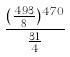Convert formula to latex. <formula><loc_0><loc_0><loc_500><loc_500>\frac { ( \frac { 4 9 3 } { 8 } ) ^ { 4 7 0 } } { \frac { 3 1 } { 4 } }</formula> 